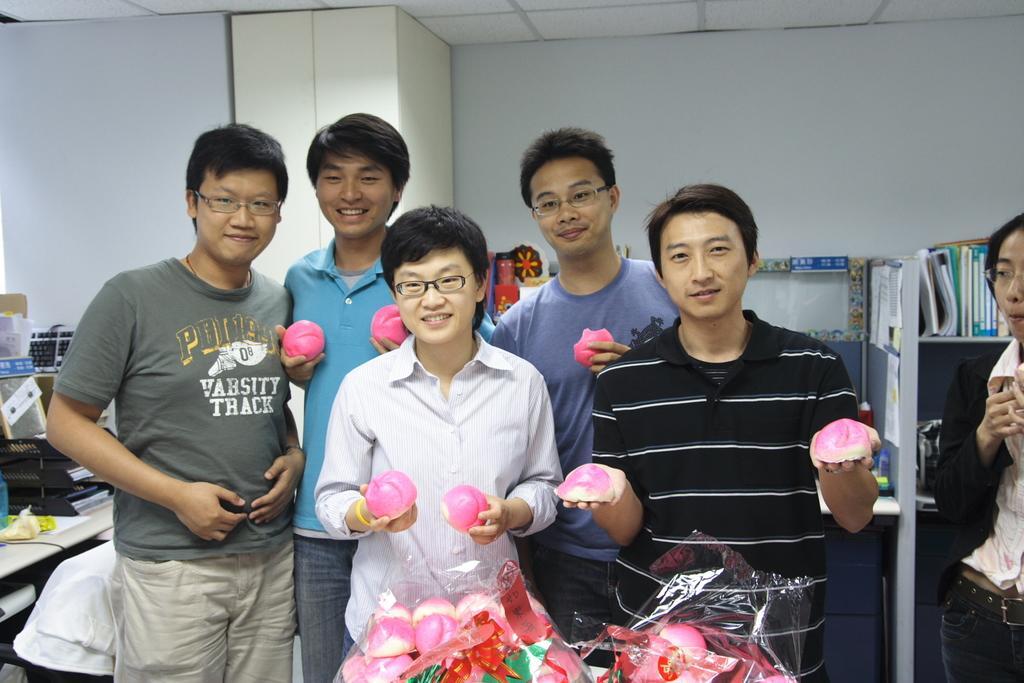Can you describe this image briefly? In this image we can see a few people standing and holding some objects, behind that we can see shelf unit and a few books, on the right we can see few objects, we can see the wall. 